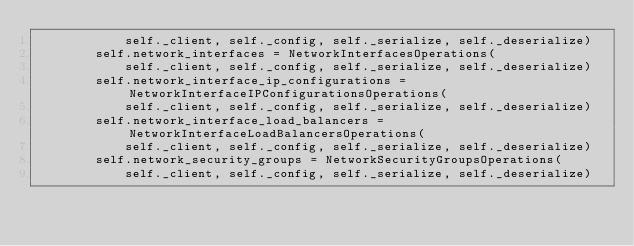Convert code to text. <code><loc_0><loc_0><loc_500><loc_500><_Python_>            self._client, self._config, self._serialize, self._deserialize)
        self.network_interfaces = NetworkInterfacesOperations(
            self._client, self._config, self._serialize, self._deserialize)
        self.network_interface_ip_configurations = NetworkInterfaceIPConfigurationsOperations(
            self._client, self._config, self._serialize, self._deserialize)
        self.network_interface_load_balancers = NetworkInterfaceLoadBalancersOperations(
            self._client, self._config, self._serialize, self._deserialize)
        self.network_security_groups = NetworkSecurityGroupsOperations(
            self._client, self._config, self._serialize, self._deserialize)</code> 